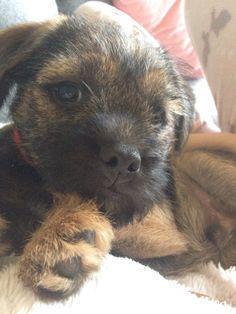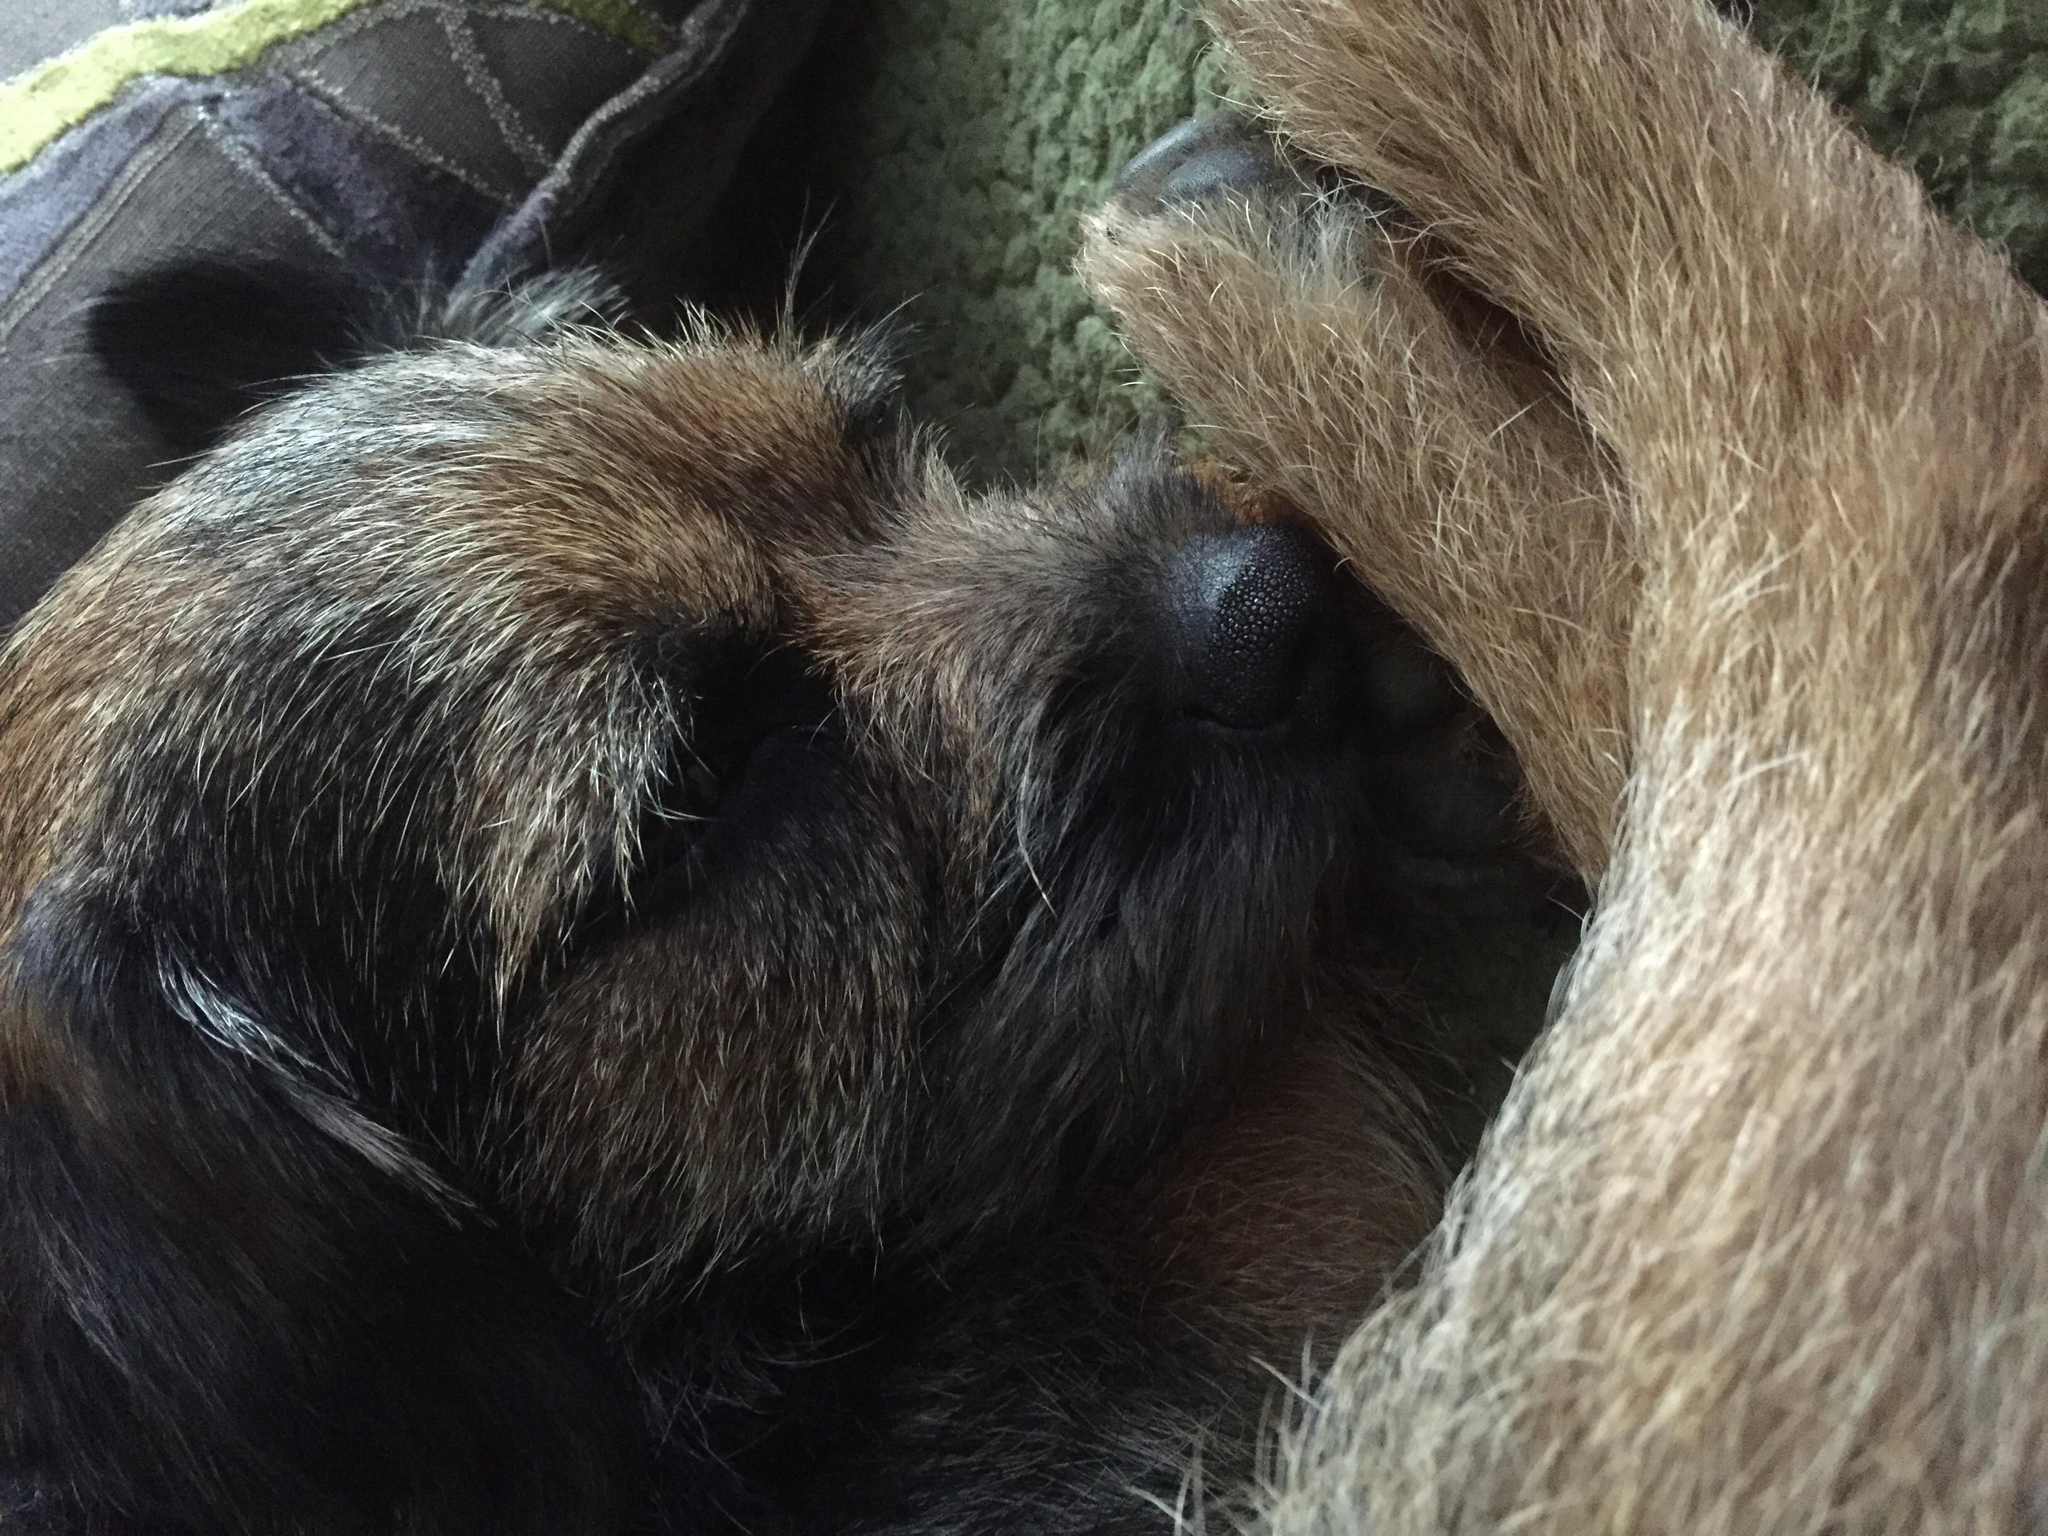The first image is the image on the left, the second image is the image on the right. For the images shown, is this caption "The right image contains one dog standing in the grass with its tail hanging down, its mouth open, and something around its neck." true? Answer yes or no. No. The first image is the image on the left, the second image is the image on the right. For the images displayed, is the sentence "There is exactly one dog in every photo and no dogs have their mouths open." factually correct? Answer yes or no. Yes. 